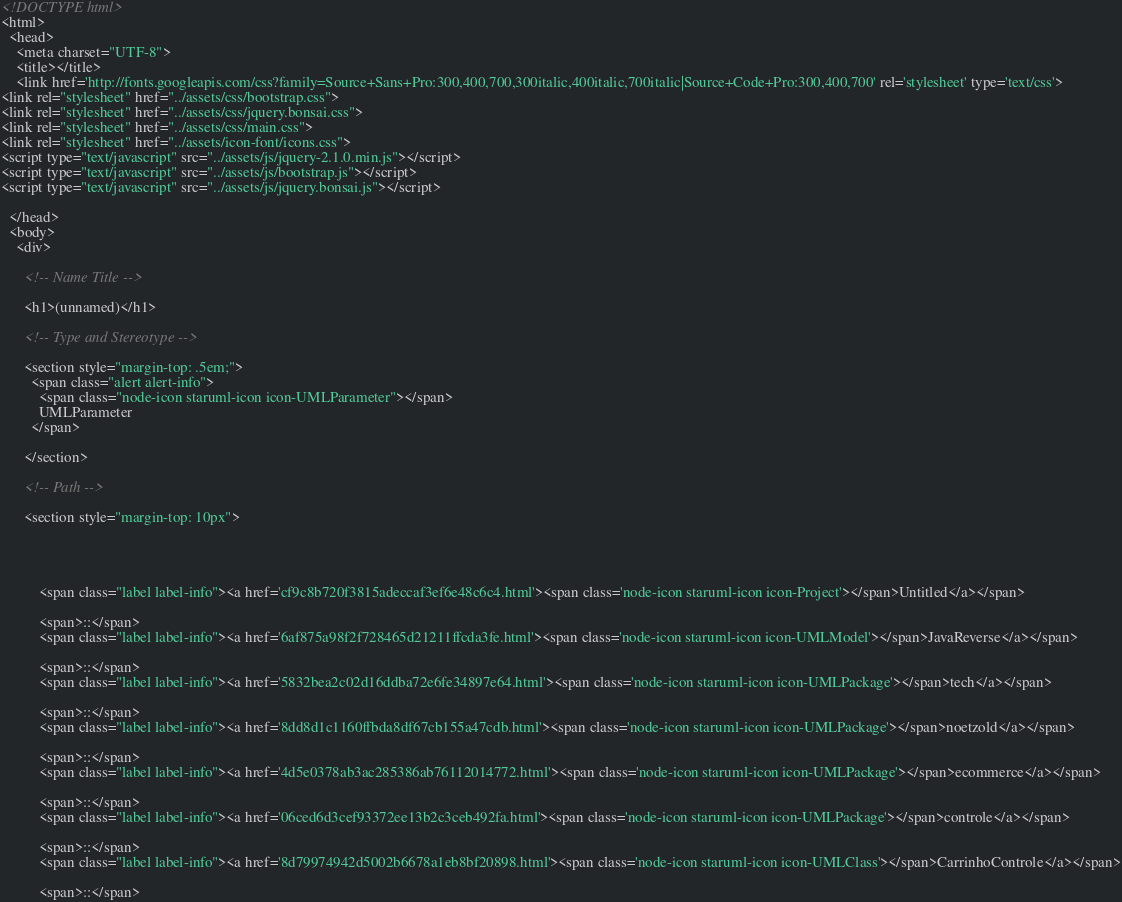Convert code to text. <code><loc_0><loc_0><loc_500><loc_500><_HTML_><!DOCTYPE html>
<html>
  <head>
    <meta charset="UTF-8">
    <title></title>
    <link href='http://fonts.googleapis.com/css?family=Source+Sans+Pro:300,400,700,300italic,400italic,700italic|Source+Code+Pro:300,400,700' rel='stylesheet' type='text/css'>
<link rel="stylesheet" href="../assets/css/bootstrap.css">
<link rel="stylesheet" href="../assets/css/jquery.bonsai.css">
<link rel="stylesheet" href="../assets/css/main.css">
<link rel="stylesheet" href="../assets/icon-font/icons.css">
<script type="text/javascript" src="../assets/js/jquery-2.1.0.min.js"></script>
<script type="text/javascript" src="../assets/js/bootstrap.js"></script>
<script type="text/javascript" src="../assets/js/jquery.bonsai.js"></script>

  </head>
  <body>
    <div>

      <!-- Name Title -->

      <h1>(unnamed)</h1>

      <!-- Type and Stereotype -->

      <section style="margin-top: .5em;">
        <span class="alert alert-info">
          <span class="node-icon staruml-icon icon-UMLParameter"></span>
          UMLParameter
        </span>
        
      </section>

      <!-- Path -->

      <section style="margin-top: 10px">
        
        
        
          
          <span class="label label-info"><a href='cf9c8b720f3815adeccaf3ef6e48c6c4.html'><span class='node-icon staruml-icon icon-Project'></span>Untitled</a></span>
        
          <span>::</span>
          <span class="label label-info"><a href='6af875a98f2f728465d21211ffcda3fe.html'><span class='node-icon staruml-icon icon-UMLModel'></span>JavaReverse</a></span>
        
          <span>::</span>
          <span class="label label-info"><a href='5832bea2c02d16ddba72e6fe34897e64.html'><span class='node-icon staruml-icon icon-UMLPackage'></span>tech</a></span>
        
          <span>::</span>
          <span class="label label-info"><a href='8dd8d1c1160ffbda8df67cb155a47cdb.html'><span class='node-icon staruml-icon icon-UMLPackage'></span>noetzold</a></span>
        
          <span>::</span>
          <span class="label label-info"><a href='4d5e0378ab3ac285386ab76112014772.html'><span class='node-icon staruml-icon icon-UMLPackage'></span>ecommerce</a></span>
        
          <span>::</span>
          <span class="label label-info"><a href='06ced6d3cef93372ee13b2c3ceb492fa.html'><span class='node-icon staruml-icon icon-UMLPackage'></span>controle</a></span>
        
          <span>::</span>
          <span class="label label-info"><a href='8d79974942d5002b6678a1eb8bf20898.html'><span class='node-icon staruml-icon icon-UMLClass'></span>CarrinhoControle</a></span>
        
          <span>::</span></code> 